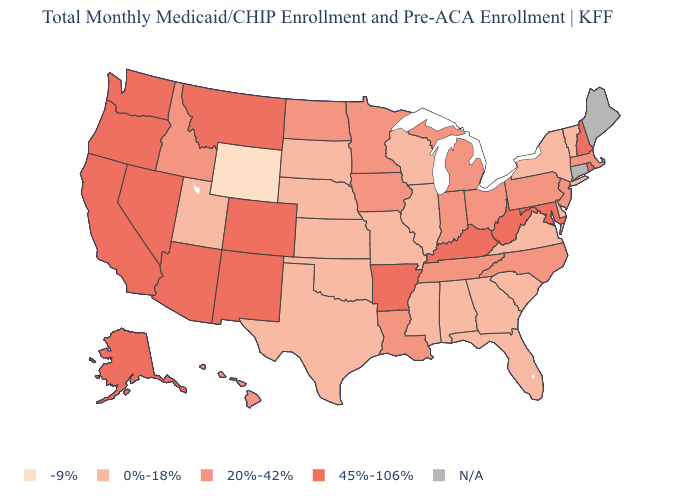Name the states that have a value in the range 20%-42%?
Be succinct. Hawaii, Idaho, Indiana, Iowa, Louisiana, Massachusetts, Michigan, Minnesota, New Jersey, North Carolina, North Dakota, Ohio, Pennsylvania, Tennessee. What is the value of New Jersey?
Write a very short answer. 20%-42%. Among the states that border Alabama , which have the highest value?
Quick response, please. Tennessee. Does the map have missing data?
Be succinct. Yes. Is the legend a continuous bar?
Write a very short answer. No. Does New Jersey have the highest value in the USA?
Write a very short answer. No. What is the value of Ohio?
Answer briefly. 20%-42%. What is the value of Mississippi?
Write a very short answer. 0%-18%. Name the states that have a value in the range 0%-18%?
Concise answer only. Alabama, Delaware, Florida, Georgia, Illinois, Kansas, Mississippi, Missouri, Nebraska, New York, Oklahoma, South Carolina, South Dakota, Texas, Utah, Vermont, Virginia, Wisconsin. Does Kansas have the highest value in the MidWest?
Quick response, please. No. Which states have the lowest value in the MidWest?
Write a very short answer. Illinois, Kansas, Missouri, Nebraska, South Dakota, Wisconsin. What is the highest value in states that border Alabama?
Concise answer only. 20%-42%. Name the states that have a value in the range -9%?
Give a very brief answer. Wyoming. Name the states that have a value in the range N/A?
Concise answer only. Connecticut, Maine. 